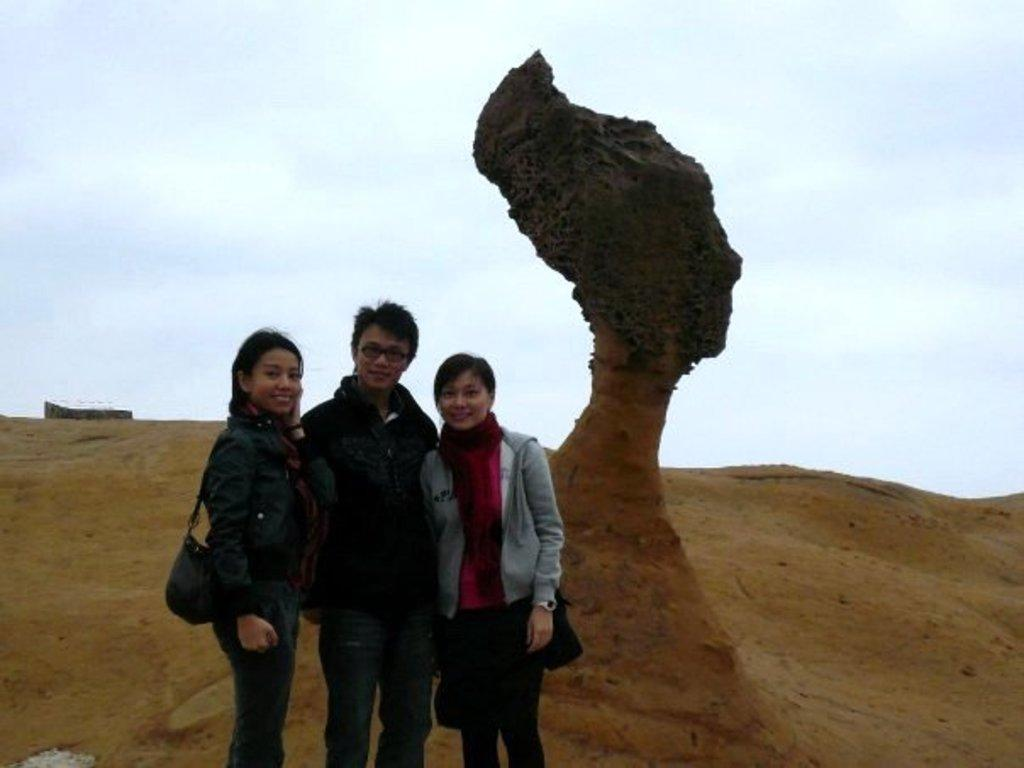How many people are standing on the left side of the image? There are three persons standing on the left side of the image. What can be seen on the right side of the image? There is a sculpture on the right side of the image. What is visible in the background of the image? The sky is visible in the background of the image. How many cups are being held by the persons in the image? There is no mention of cups in the image, so we cannot determine how many cups are being held. What type of mass is present in the image? There is no mention of mass in the image, so we cannot determine what type of mass is present. 